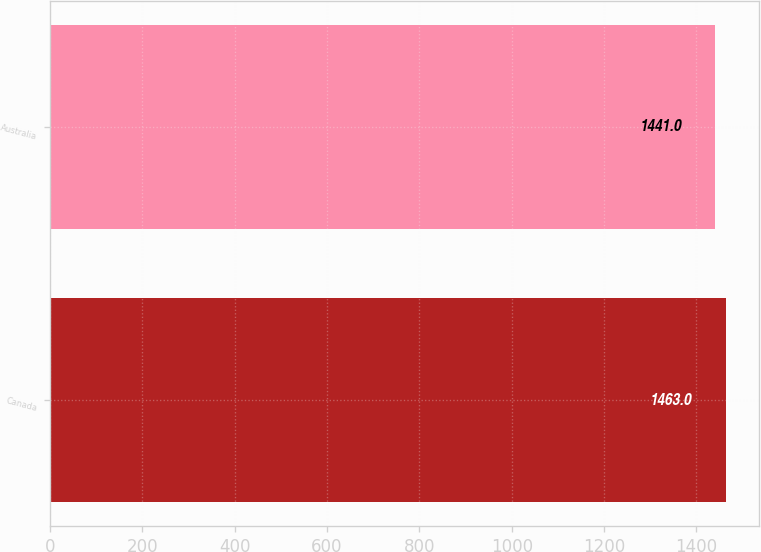Convert chart. <chart><loc_0><loc_0><loc_500><loc_500><bar_chart><fcel>Canada<fcel>Australia<nl><fcel>1463<fcel>1441<nl></chart> 